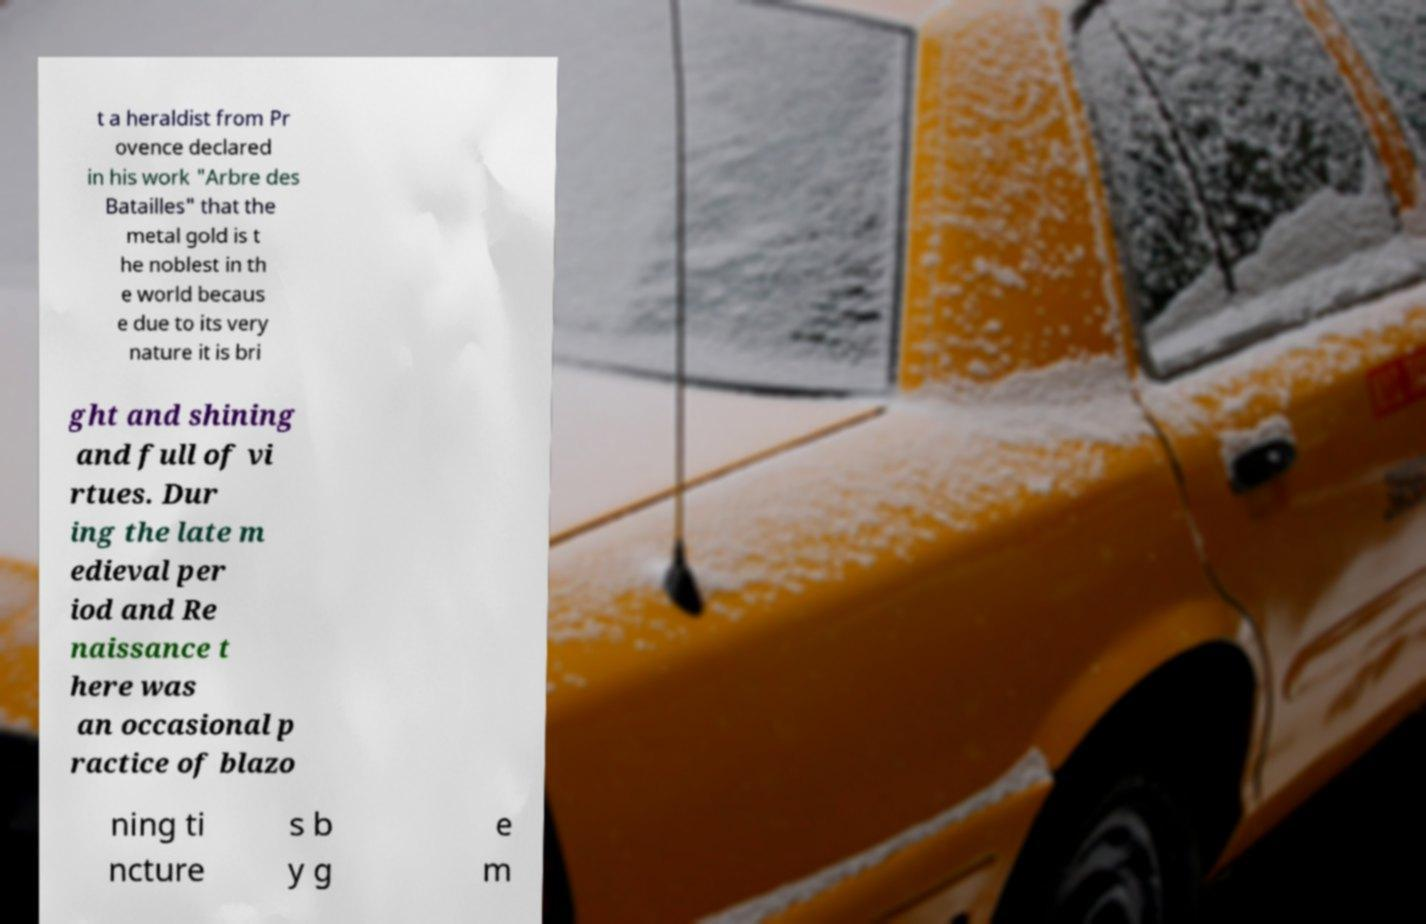I need the written content from this picture converted into text. Can you do that? t a heraldist from Pr ovence declared in his work "Arbre des Batailles" that the metal gold is t he noblest in th e world becaus e due to its very nature it is bri ght and shining and full of vi rtues. Dur ing the late m edieval per iod and Re naissance t here was an occasional p ractice of blazo ning ti ncture s b y g e m 